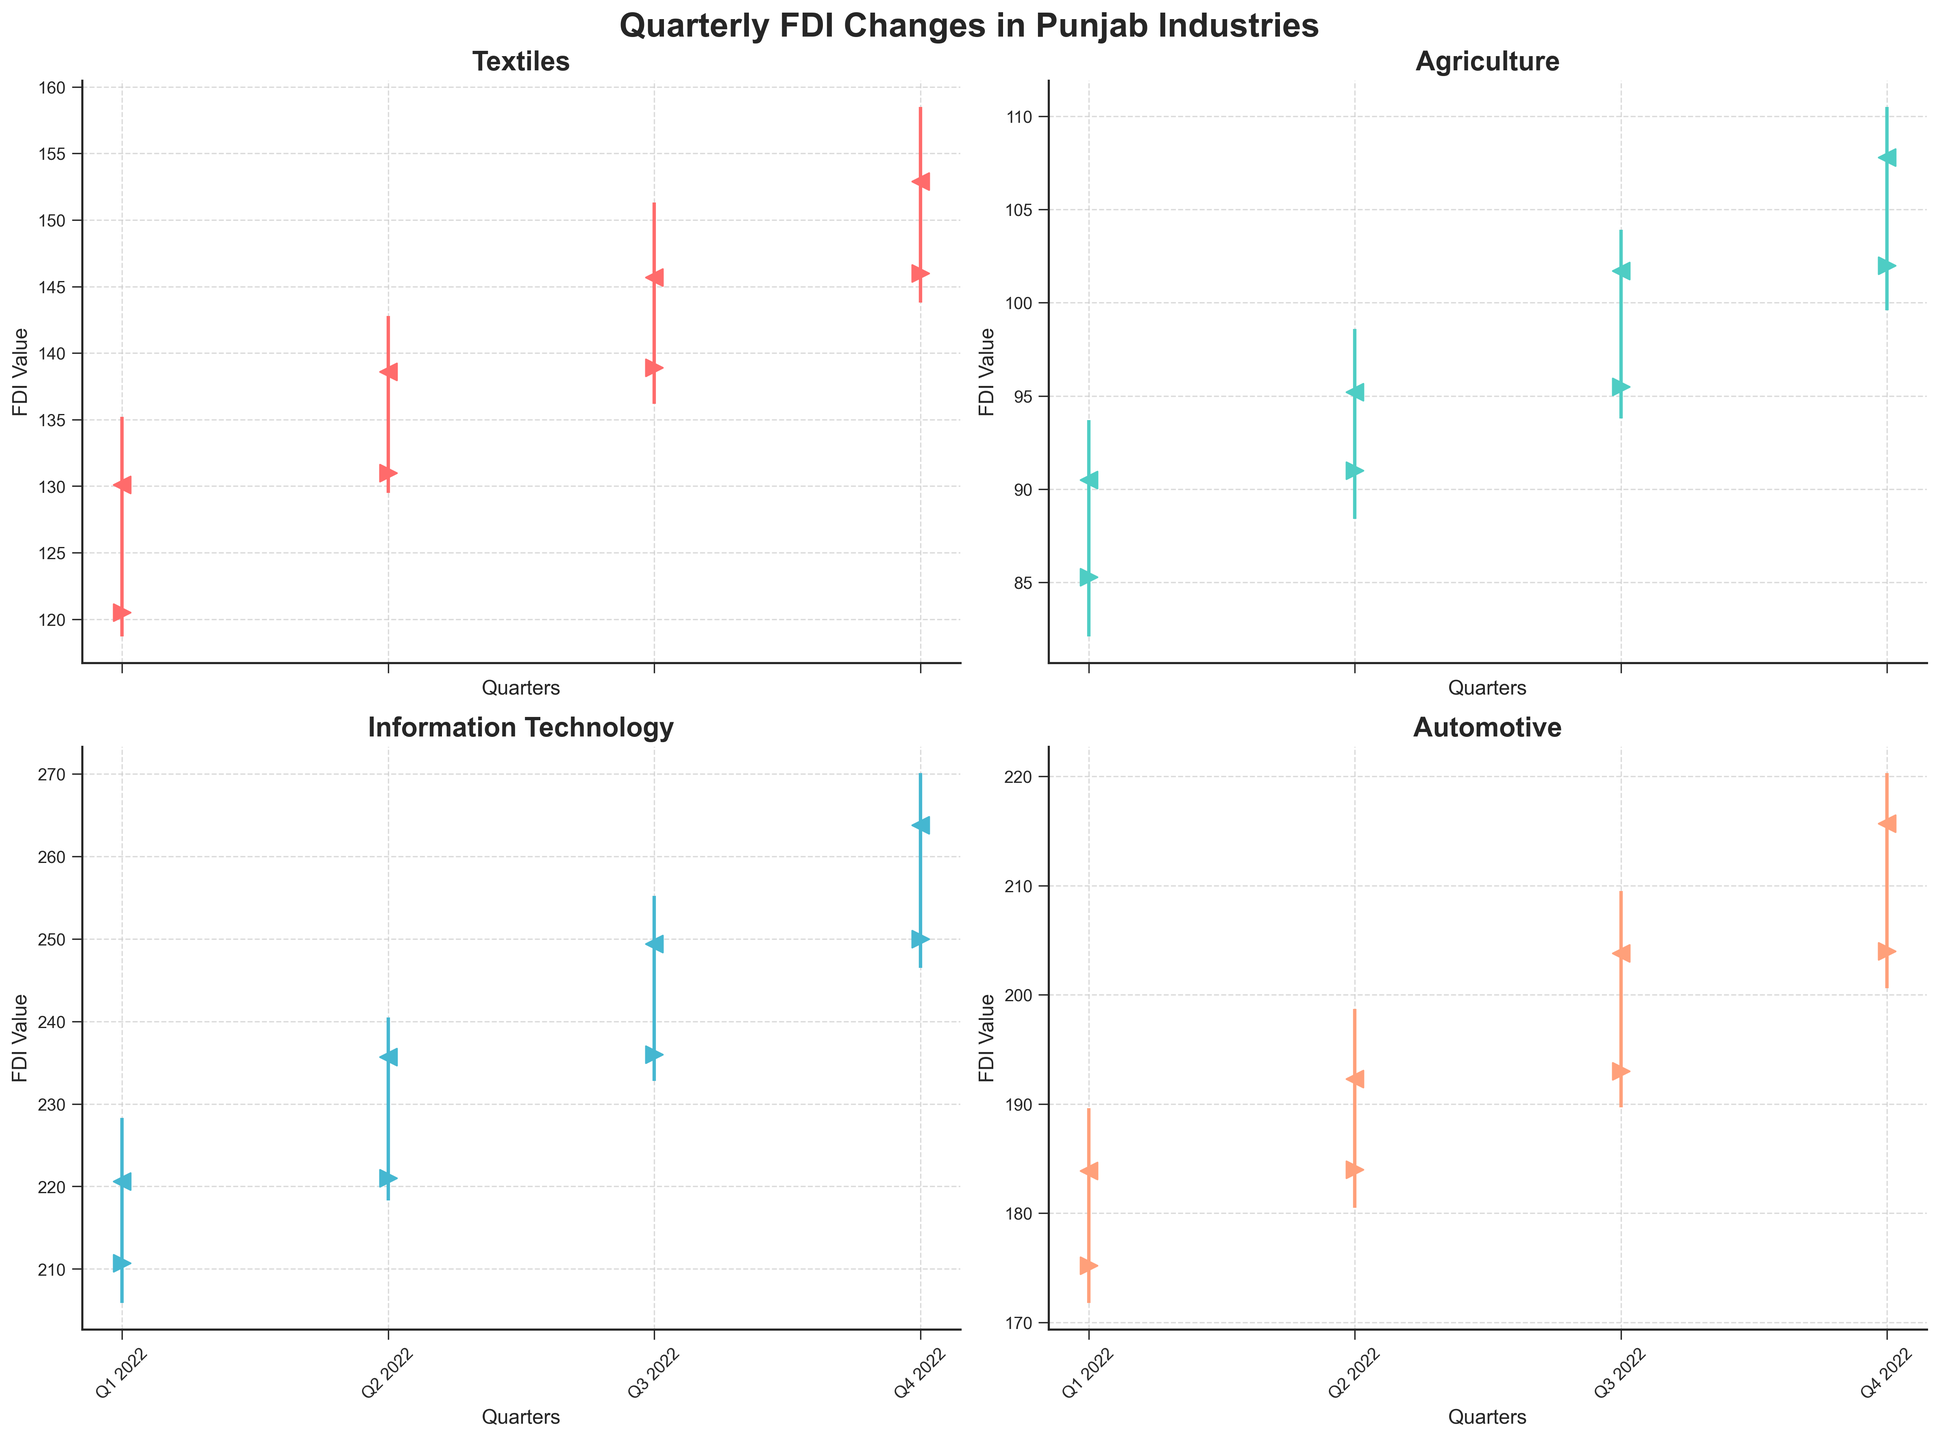Which industry showed the highest FDI value in Q4 2022? The IT industry's High value is 270.1, Textiles is 158.5, Agriculture is 110.5, and Automotive is 220.3. The highest of these is in the IT industry.
Answer: Information Technology Which industry saw the greatest increase in FDI value from Q1 2022 to Q4 2022? Comparing the Close values from Q1 to Q4: Textiles increased from 130.1 to 152.9, Agriculture from 90.5 to 107.8, IT from 220.6 to 263.8, and Automotive from 183.9 to 215.7. The IT industry had the largest increase (43.2).
Answer: Information Technology In which quarter did the Agriculture industry experience its highest Low value? From the plotted Lows for Agriculture: Q1 is 82.1, Q2 is 88.4, Q3 is 93.8, and Q4 is 99.6. The highest Low value is in Q4.
Answer: Q4 2022 What is the trend in the FDI closing values for the Textiles industry over 2022? The Textiles industry’s Close values are 130.1 in Q1, 138.6 in Q2, 145.7 in Q3, and 152.9 in Q4, indicating a consistent rising trend.
Answer: Increasing Which industry had the smallest range (High - Low) in Q2 2022? For Q2 2022: Textiles range is 142.8-129.5=13.3, Agriculture is 98.6-88.4=10.2, IT is 240.5-218.3=22.2, Automotive is 198.7-180.5=18.2. Agriculture has the smallest range (10.2).
Answer: Agriculture Did any industry have a higher closing value in Q3 2022 than its opening value in Q4 2022? Textiles closed at 145.7 in Q3 and opened at 146.0 in Q4; Agriculture closed at 101.7 and opened at 102.0; IT closed at 249.4 and opened at 250.0; Automotive closed at 203.8 and opened at 204.0. No industry had a higher Q3 close than Q4 open.
Answer: No Which industry had the highest volatility (difference between High and Low) in Q4 2022? The ranges in Q4 2022 are: Textiles 158.5-143.8=14.7, Agriculture 110.5-99.6=10.9, IT 270.1-246.5=23.6, Automotive 220.3-200.6=19.7. IT had the highest volatility (23.6).
Answer: Information Technology Which quarter showed the largest growth in FDI for the Automotive industry? Comparing Close values: Q1 to Q2 is 8.4, Q2 to Q3 is 11.5, Q3 to Q4 is 11.9. The largest growth is from Q3 to Q4.
Answer: Q3 to Q4 2022 